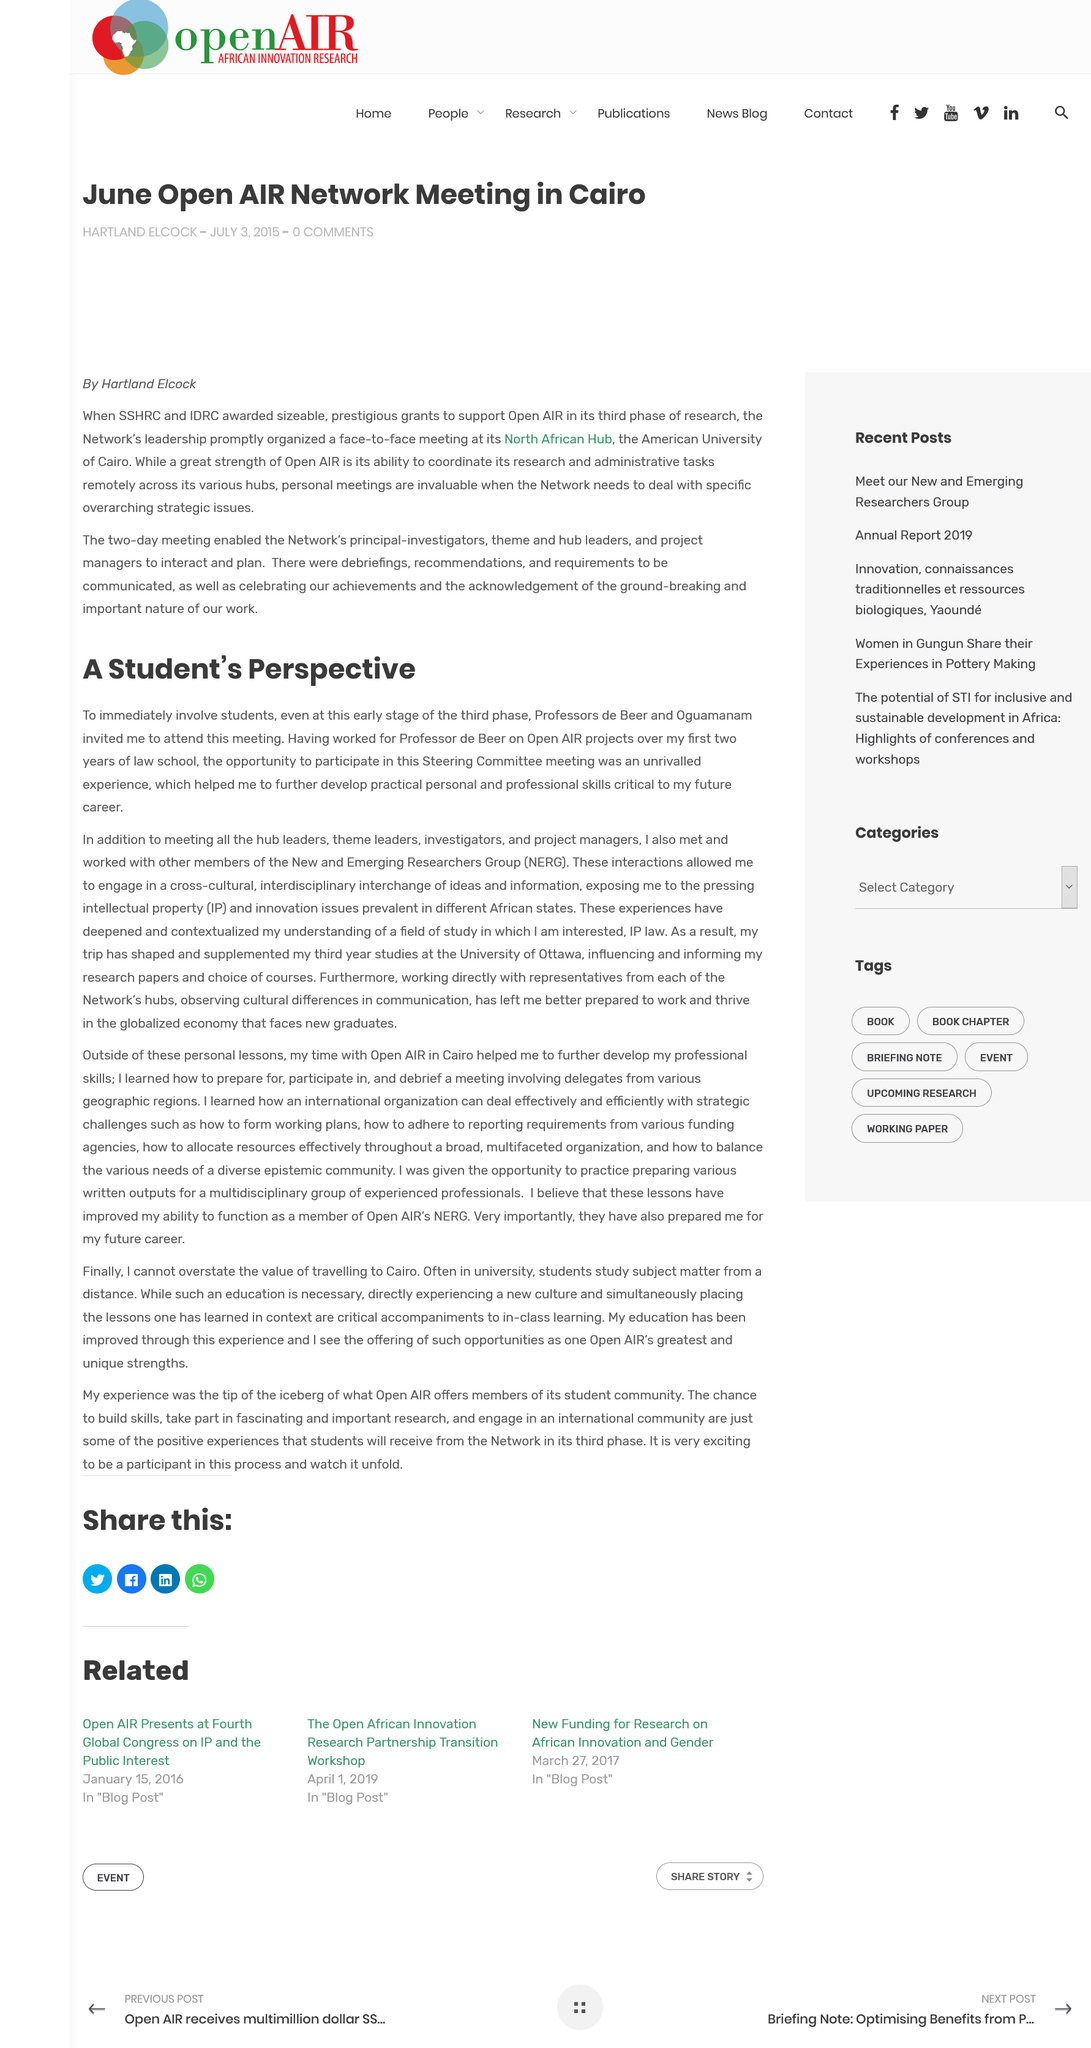Give some essential details in this illustration. Two professors invited the author to the meeting. The article "A Student's Perspective" refers to the Steering Committee meeting. The names of the professors are Professors de Beer and Oguamanam. 